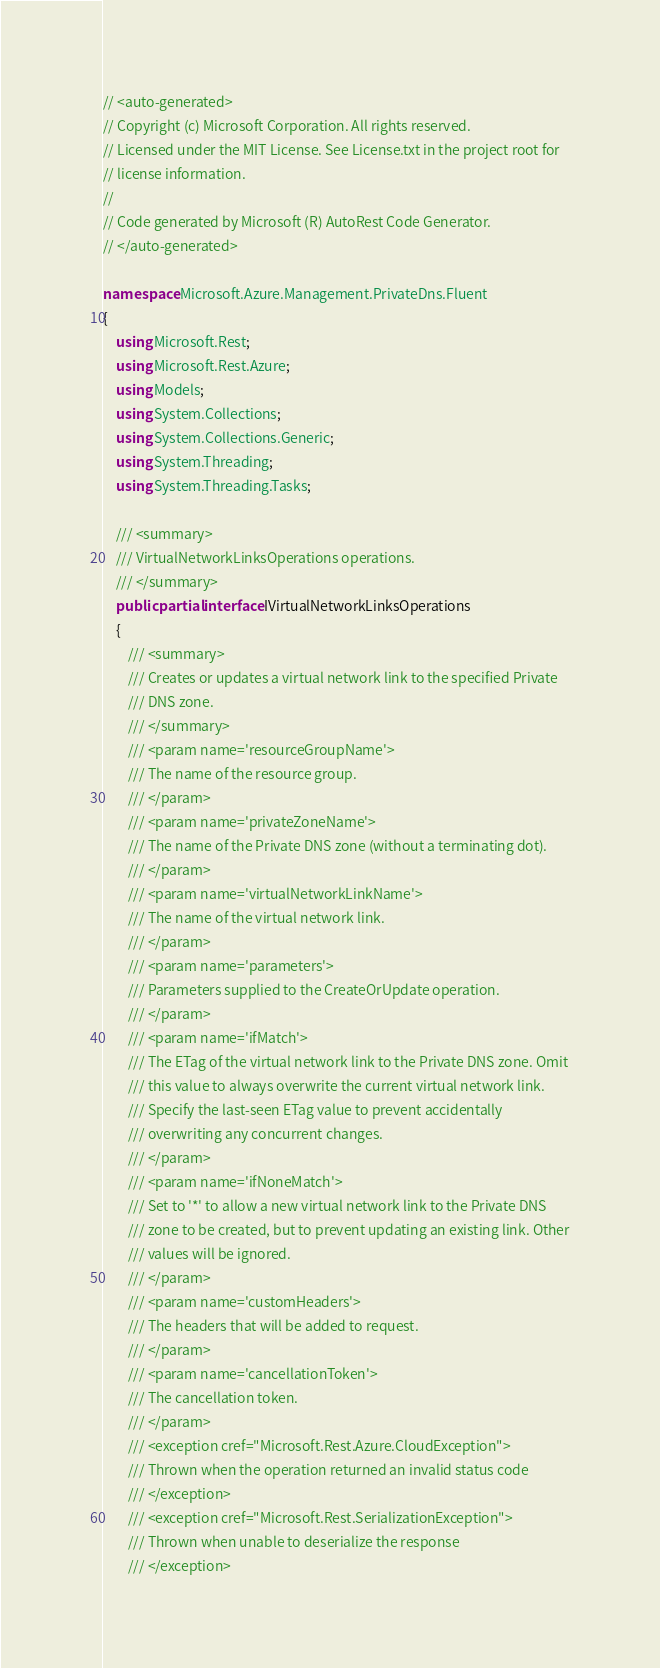Convert code to text. <code><loc_0><loc_0><loc_500><loc_500><_C#_>// <auto-generated>
// Copyright (c) Microsoft Corporation. All rights reserved.
// Licensed under the MIT License. See License.txt in the project root for
// license information.
//
// Code generated by Microsoft (R) AutoRest Code Generator.
// </auto-generated>

namespace Microsoft.Azure.Management.PrivateDns.Fluent
{
    using Microsoft.Rest;
    using Microsoft.Rest.Azure;
    using Models;
    using System.Collections;
    using System.Collections.Generic;
    using System.Threading;
    using System.Threading.Tasks;

    /// <summary>
    /// VirtualNetworkLinksOperations operations.
    /// </summary>
    public partial interface IVirtualNetworkLinksOperations
    {
        /// <summary>
        /// Creates or updates a virtual network link to the specified Private
        /// DNS zone.
        /// </summary>
        /// <param name='resourceGroupName'>
        /// The name of the resource group.
        /// </param>
        /// <param name='privateZoneName'>
        /// The name of the Private DNS zone (without a terminating dot).
        /// </param>
        /// <param name='virtualNetworkLinkName'>
        /// The name of the virtual network link.
        /// </param>
        /// <param name='parameters'>
        /// Parameters supplied to the CreateOrUpdate operation.
        /// </param>
        /// <param name='ifMatch'>
        /// The ETag of the virtual network link to the Private DNS zone. Omit
        /// this value to always overwrite the current virtual network link.
        /// Specify the last-seen ETag value to prevent accidentally
        /// overwriting any concurrent changes.
        /// </param>
        /// <param name='ifNoneMatch'>
        /// Set to '*' to allow a new virtual network link to the Private DNS
        /// zone to be created, but to prevent updating an existing link. Other
        /// values will be ignored.
        /// </param>
        /// <param name='customHeaders'>
        /// The headers that will be added to request.
        /// </param>
        /// <param name='cancellationToken'>
        /// The cancellation token.
        /// </param>
        /// <exception cref="Microsoft.Rest.Azure.CloudException">
        /// Thrown when the operation returned an invalid status code
        /// </exception>
        /// <exception cref="Microsoft.Rest.SerializationException">
        /// Thrown when unable to deserialize the response
        /// </exception></code> 